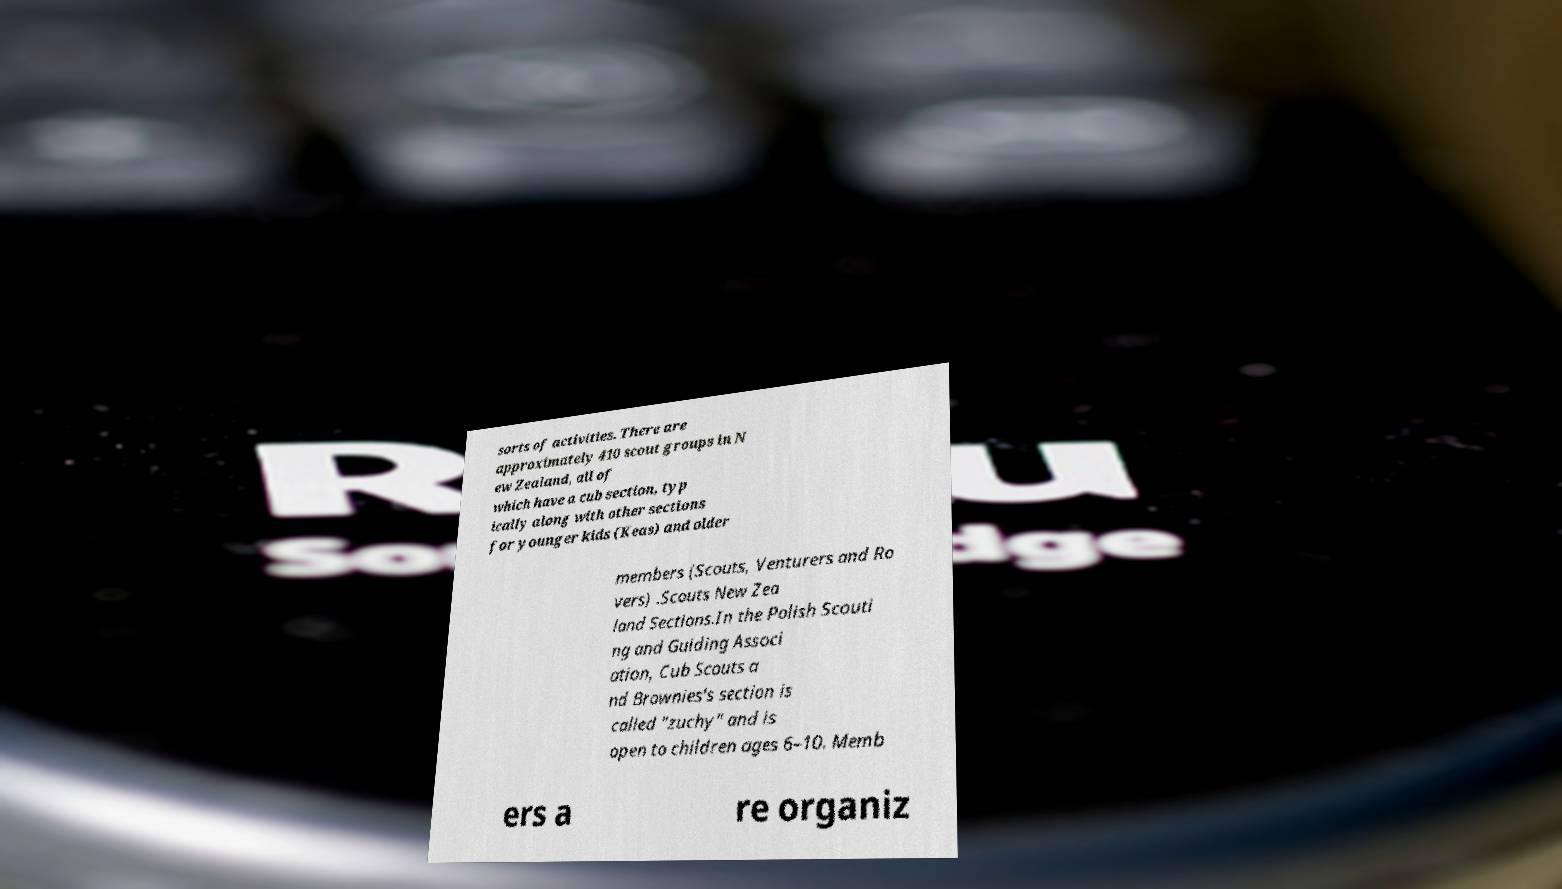I need the written content from this picture converted into text. Can you do that? sorts of activities. There are approximately 410 scout groups in N ew Zealand, all of which have a cub section, typ ically along with other sections for younger kids (Keas) and older members (Scouts, Venturers and Ro vers) .Scouts New Zea land Sections.In the Polish Scouti ng and Guiding Associ ation, Cub Scouts a nd Brownies's section is called "zuchy" and is open to children ages 6–10. Memb ers a re organiz 